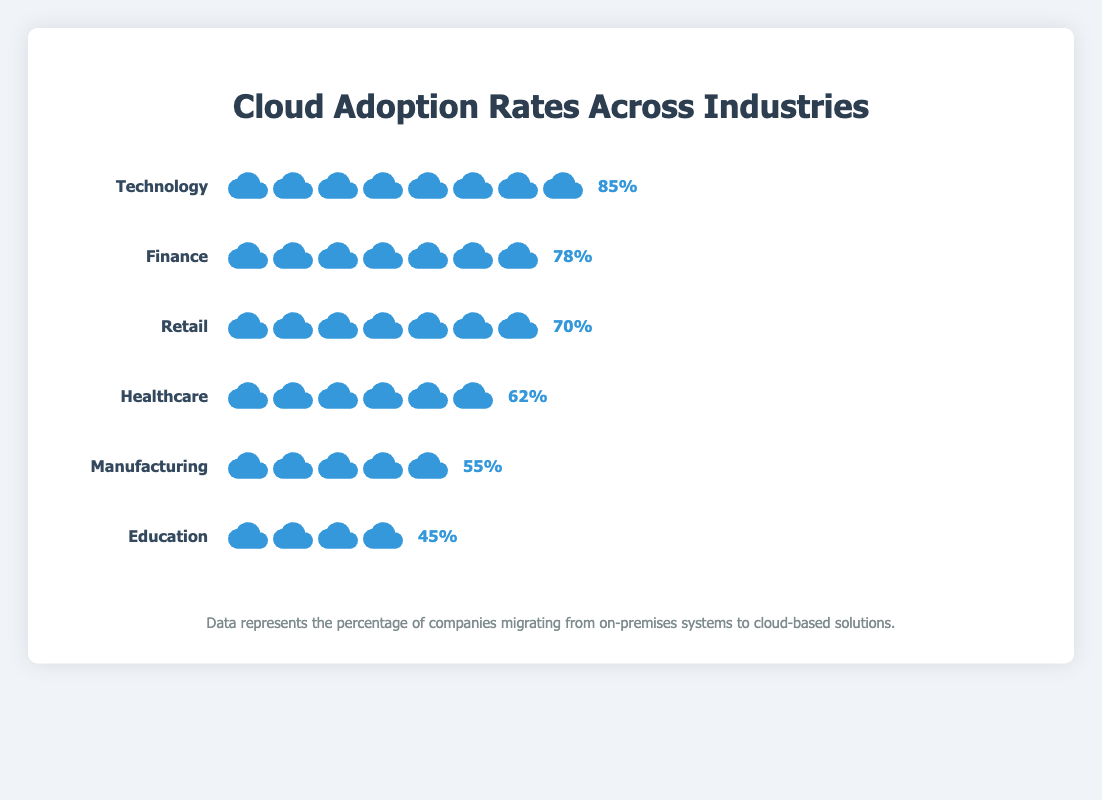Which industry has the highest adoption rate of cloud-based solutions? The Technology industry has 85% cloud adoption, which is the highest among the listed industries.
Answer: Technology Which industry has the second highest cloud adoption rate? The Finance industry has the second highest adoption rate with 78% after Technology.
Answer: Finance What is the title of the figure? The title of the figure is "Cloud Adoption Rates Across Industries" as displayed at the top.
Answer: Cloud Adoption Rates Across Industries Which industries have cloud adoption rates above 70%? Both Technology (85%) and Finance (78%) have cloud adoption rates above 70%.
Answer: Technology, Finance What is the difference in cloud adoption rates between Technology and Education? The cloud adoption rate for Technology is 85% and for Education is 45%. The difference is 85% - 45% = 40%.
Answer: 40% How many industries have their cloud adoption rates below 60%? Three industries (Education at 45%, Manufacturing at 55%, and Healthcare at 62%) have cloud adoption rates below 60%.
Answer: 3 Which industry has the lowest cloud adoption rate? The Education industry has the lowest cloud adoption rate at 45%.
Answer: Education What is the average cloud adoption rate across all listed industries? Add the percentages of all industries (85% + 78% + 70% + 62% + 55% + 45%) = 395%. Divide by the number of industries (395 / 6) to get the average, which is approximately 65.83%.
Answer: 65.83% How many cloud icons represent the cloud adoption rate for Healthcare? The Healthcare industry has an adoption rate of 62%, represented by roughly 6 cloud icons.
Answer: 6 What can be inferred about the relative readiness of industries to migrate to cloud-based solutions based on their adoption rates? Technology and Finance show high readiness with adoption rates above 70%, indicating these industries are more inclined towards cloud migration. Industries like Education and Manufacturing with lower rates imply slower adoption or higher dependency on legacy systems.
Answer: Varies 